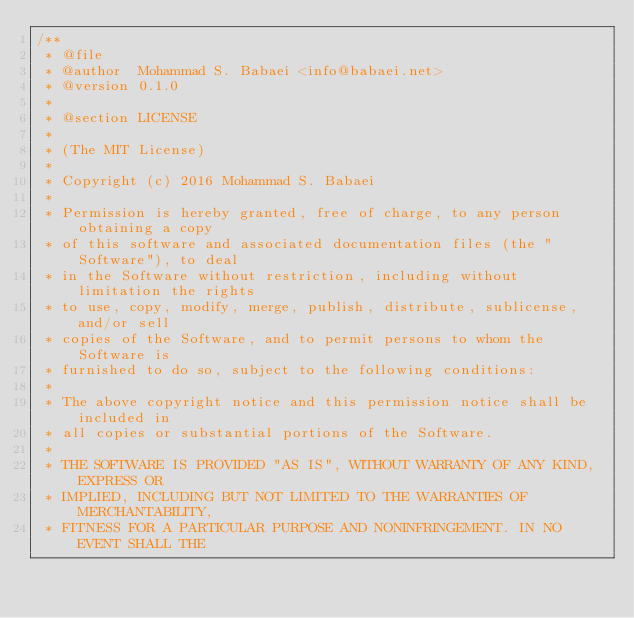Convert code to text. <code><loc_0><loc_0><loc_500><loc_500><_C++_>/**
 * @file
 * @author  Mohammad S. Babaei <info@babaei.net>
 * @version 0.1.0
 *
 * @section LICENSE
 *
 * (The MIT License)
 *
 * Copyright (c) 2016 Mohammad S. Babaei
 *
 * Permission is hereby granted, free of charge, to any person obtaining a copy
 * of this software and associated documentation files (the "Software"), to deal
 * in the Software without restriction, including without limitation the rights
 * to use, copy, modify, merge, publish, distribute, sublicense, and/or sell
 * copies of the Software, and to permit persons to whom the Software is
 * furnished to do so, subject to the following conditions:
 *
 * The above copyright notice and this permission notice shall be included in
 * all copies or substantial portions of the Software.
 *
 * THE SOFTWARE IS PROVIDED "AS IS", WITHOUT WARRANTY OF ANY KIND, EXPRESS OR
 * IMPLIED, INCLUDING BUT NOT LIMITED TO THE WARRANTIES OF MERCHANTABILITY,
 * FITNESS FOR A PARTICULAR PURPOSE AND NONINFRINGEMENT. IN NO EVENT SHALL THE</code> 